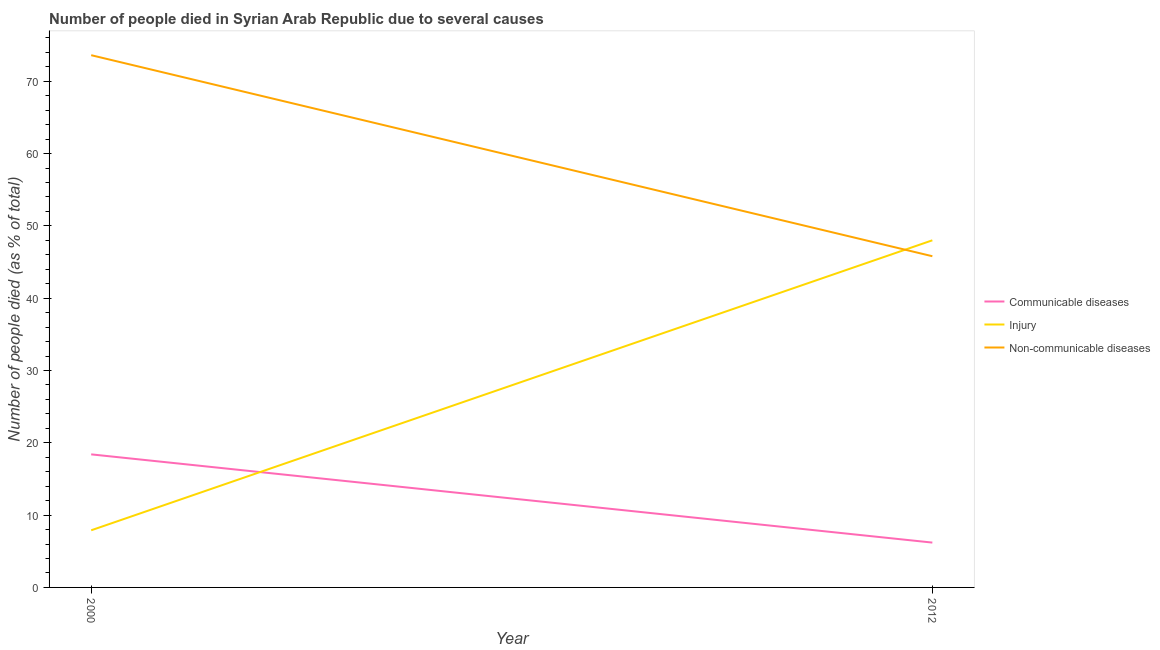Is the number of lines equal to the number of legend labels?
Provide a succinct answer. Yes. What is the number of people who died of injury in 2012?
Give a very brief answer. 48. Across all years, what is the maximum number of people who dies of non-communicable diseases?
Keep it short and to the point. 73.6. Across all years, what is the minimum number of people who dies of non-communicable diseases?
Your answer should be compact. 45.8. In which year was the number of people who died of injury maximum?
Ensure brevity in your answer.  2012. What is the total number of people who died of injury in the graph?
Provide a succinct answer. 55.9. What is the difference between the number of people who died of injury in 2000 and that in 2012?
Your answer should be compact. -40.1. What is the difference between the number of people who died of injury in 2012 and the number of people who dies of non-communicable diseases in 2000?
Provide a succinct answer. -25.6. What is the average number of people who died of communicable diseases per year?
Provide a short and direct response. 12.3. In the year 2000, what is the difference between the number of people who dies of non-communicable diseases and number of people who died of communicable diseases?
Ensure brevity in your answer.  55.2. What is the ratio of the number of people who died of injury in 2000 to that in 2012?
Your answer should be compact. 0.16. Is the number of people who dies of non-communicable diseases in 2000 less than that in 2012?
Offer a terse response. No. Is the number of people who dies of non-communicable diseases strictly greater than the number of people who died of injury over the years?
Give a very brief answer. No. How many lines are there?
Offer a very short reply. 3. How many years are there in the graph?
Your response must be concise. 2. What is the difference between two consecutive major ticks on the Y-axis?
Make the answer very short. 10. Are the values on the major ticks of Y-axis written in scientific E-notation?
Keep it short and to the point. No. Does the graph contain grids?
Ensure brevity in your answer.  No. Where does the legend appear in the graph?
Provide a short and direct response. Center right. How many legend labels are there?
Your answer should be compact. 3. What is the title of the graph?
Ensure brevity in your answer.  Number of people died in Syrian Arab Republic due to several causes. What is the label or title of the X-axis?
Your answer should be compact. Year. What is the label or title of the Y-axis?
Offer a terse response. Number of people died (as % of total). What is the Number of people died (as % of total) of Communicable diseases in 2000?
Provide a succinct answer. 18.4. What is the Number of people died (as % of total) in Injury in 2000?
Offer a very short reply. 7.9. What is the Number of people died (as % of total) in Non-communicable diseases in 2000?
Make the answer very short. 73.6. What is the Number of people died (as % of total) of Injury in 2012?
Keep it short and to the point. 48. What is the Number of people died (as % of total) of Non-communicable diseases in 2012?
Ensure brevity in your answer.  45.8. Across all years, what is the maximum Number of people died (as % of total) of Communicable diseases?
Your answer should be compact. 18.4. Across all years, what is the maximum Number of people died (as % of total) of Injury?
Your answer should be compact. 48. Across all years, what is the maximum Number of people died (as % of total) of Non-communicable diseases?
Provide a short and direct response. 73.6. Across all years, what is the minimum Number of people died (as % of total) in Non-communicable diseases?
Offer a terse response. 45.8. What is the total Number of people died (as % of total) of Communicable diseases in the graph?
Your response must be concise. 24.6. What is the total Number of people died (as % of total) in Injury in the graph?
Your answer should be very brief. 55.9. What is the total Number of people died (as % of total) in Non-communicable diseases in the graph?
Give a very brief answer. 119.4. What is the difference between the Number of people died (as % of total) in Injury in 2000 and that in 2012?
Keep it short and to the point. -40.1. What is the difference between the Number of people died (as % of total) of Non-communicable diseases in 2000 and that in 2012?
Keep it short and to the point. 27.8. What is the difference between the Number of people died (as % of total) in Communicable diseases in 2000 and the Number of people died (as % of total) in Injury in 2012?
Make the answer very short. -29.6. What is the difference between the Number of people died (as % of total) in Communicable diseases in 2000 and the Number of people died (as % of total) in Non-communicable diseases in 2012?
Your answer should be compact. -27.4. What is the difference between the Number of people died (as % of total) of Injury in 2000 and the Number of people died (as % of total) of Non-communicable diseases in 2012?
Provide a short and direct response. -37.9. What is the average Number of people died (as % of total) of Injury per year?
Make the answer very short. 27.95. What is the average Number of people died (as % of total) in Non-communicable diseases per year?
Provide a short and direct response. 59.7. In the year 2000, what is the difference between the Number of people died (as % of total) of Communicable diseases and Number of people died (as % of total) of Non-communicable diseases?
Provide a succinct answer. -55.2. In the year 2000, what is the difference between the Number of people died (as % of total) in Injury and Number of people died (as % of total) in Non-communicable diseases?
Your answer should be compact. -65.7. In the year 2012, what is the difference between the Number of people died (as % of total) of Communicable diseases and Number of people died (as % of total) of Injury?
Offer a very short reply. -41.8. In the year 2012, what is the difference between the Number of people died (as % of total) in Communicable diseases and Number of people died (as % of total) in Non-communicable diseases?
Provide a short and direct response. -39.6. In the year 2012, what is the difference between the Number of people died (as % of total) in Injury and Number of people died (as % of total) in Non-communicable diseases?
Offer a terse response. 2.2. What is the ratio of the Number of people died (as % of total) in Communicable diseases in 2000 to that in 2012?
Your response must be concise. 2.97. What is the ratio of the Number of people died (as % of total) of Injury in 2000 to that in 2012?
Your response must be concise. 0.16. What is the ratio of the Number of people died (as % of total) of Non-communicable diseases in 2000 to that in 2012?
Keep it short and to the point. 1.61. What is the difference between the highest and the second highest Number of people died (as % of total) in Communicable diseases?
Keep it short and to the point. 12.2. What is the difference between the highest and the second highest Number of people died (as % of total) in Injury?
Make the answer very short. 40.1. What is the difference between the highest and the second highest Number of people died (as % of total) of Non-communicable diseases?
Provide a short and direct response. 27.8. What is the difference between the highest and the lowest Number of people died (as % of total) in Communicable diseases?
Offer a terse response. 12.2. What is the difference between the highest and the lowest Number of people died (as % of total) in Injury?
Your response must be concise. 40.1. What is the difference between the highest and the lowest Number of people died (as % of total) of Non-communicable diseases?
Keep it short and to the point. 27.8. 